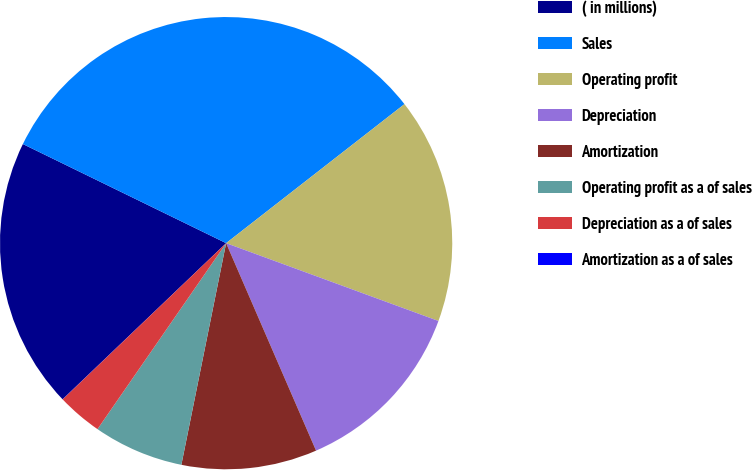Convert chart to OTSL. <chart><loc_0><loc_0><loc_500><loc_500><pie_chart><fcel>( in millions)<fcel>Sales<fcel>Operating profit<fcel>Depreciation<fcel>Amortization<fcel>Operating profit as a of sales<fcel>Depreciation as a of sales<fcel>Amortization as a of sales<nl><fcel>19.35%<fcel>32.24%<fcel>16.13%<fcel>12.9%<fcel>9.68%<fcel>6.46%<fcel>3.23%<fcel>0.01%<nl></chart> 